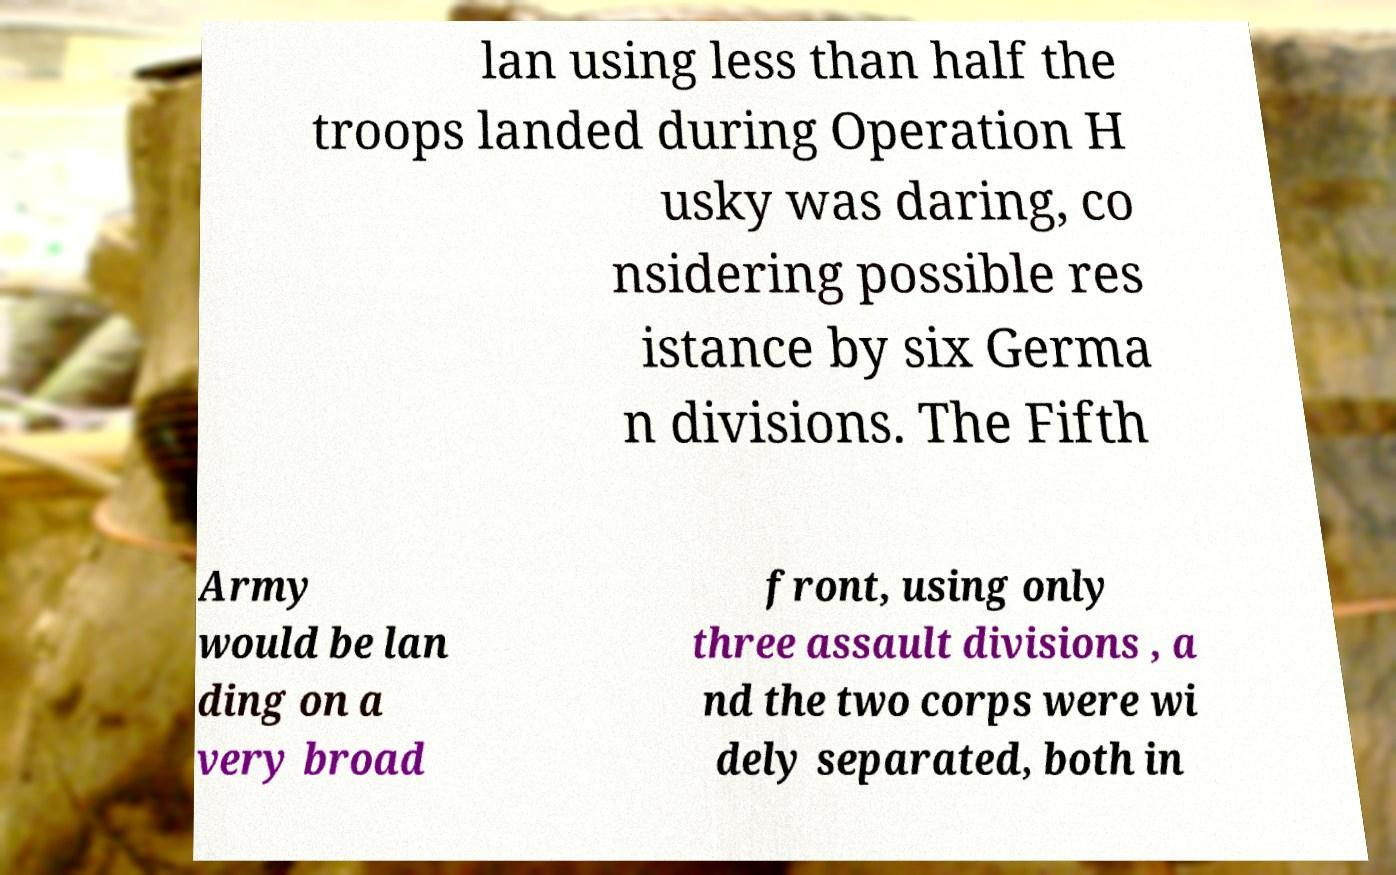Please read and relay the text visible in this image. What does it say? lan using less than half the troops landed during Operation H usky was daring, co nsidering possible res istance by six Germa n divisions. The Fifth Army would be lan ding on a very broad front, using only three assault divisions , a nd the two corps were wi dely separated, both in 